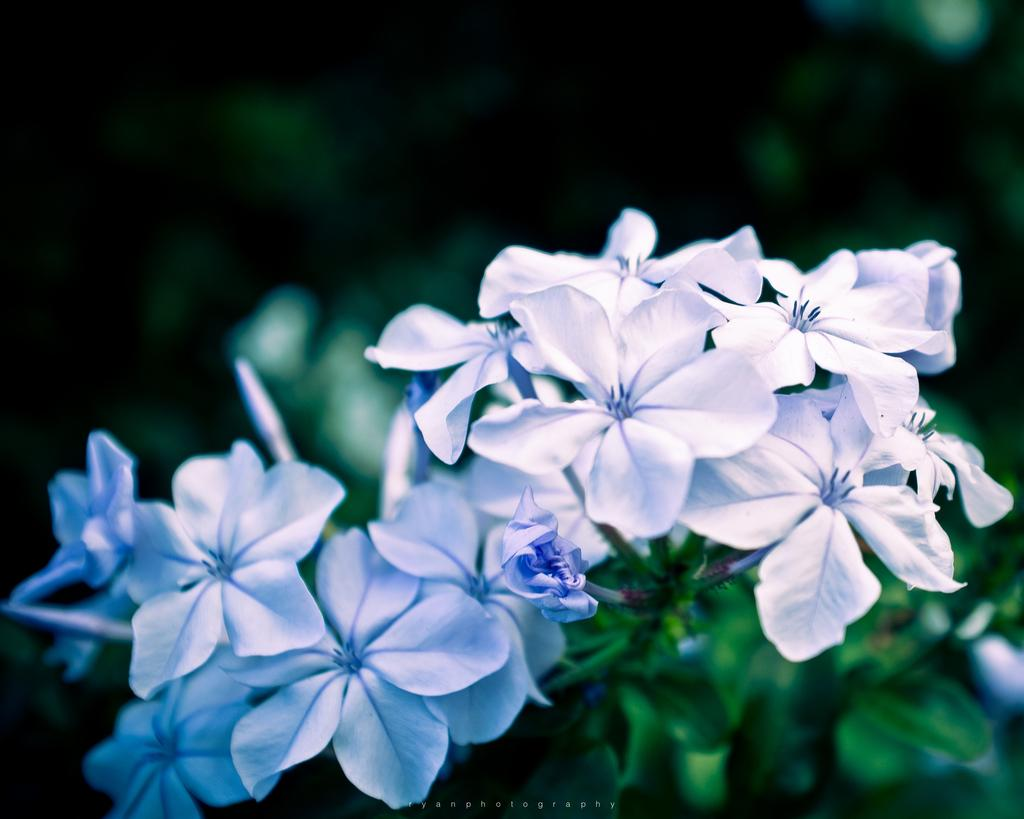What is in the foreground of the image? There are flowers in the foreground of the image. Can you describe the background of the image? The background of the image is blurred. What type of kitten can be seen playing with a debt in the image? There is no kitten or debt present in the image; it features flowers in the foreground and a blurred background. Is there a band performing in the image? There is no band present in the image. 